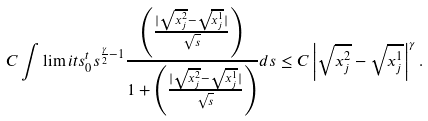<formula> <loc_0><loc_0><loc_500><loc_500>C \int \lim i t s _ { 0 } ^ { t } s ^ { \frac { \gamma } { 2 } - 1 } \frac { \left ( \frac { | \sqrt { x ^ { 2 } _ { j } } - \sqrt { x ^ { 1 } _ { j } } | } { \sqrt { s } } \right ) } { 1 + \left ( \frac { | \sqrt { x ^ { 2 } _ { j } } - \sqrt { x ^ { 1 } _ { j } } | } { \sqrt { s } } \right ) } d s \leq C \left | \sqrt { x ^ { 2 } _ { j } } - \sqrt { x ^ { 1 } _ { j } } \right | ^ { \gamma } .</formula> 